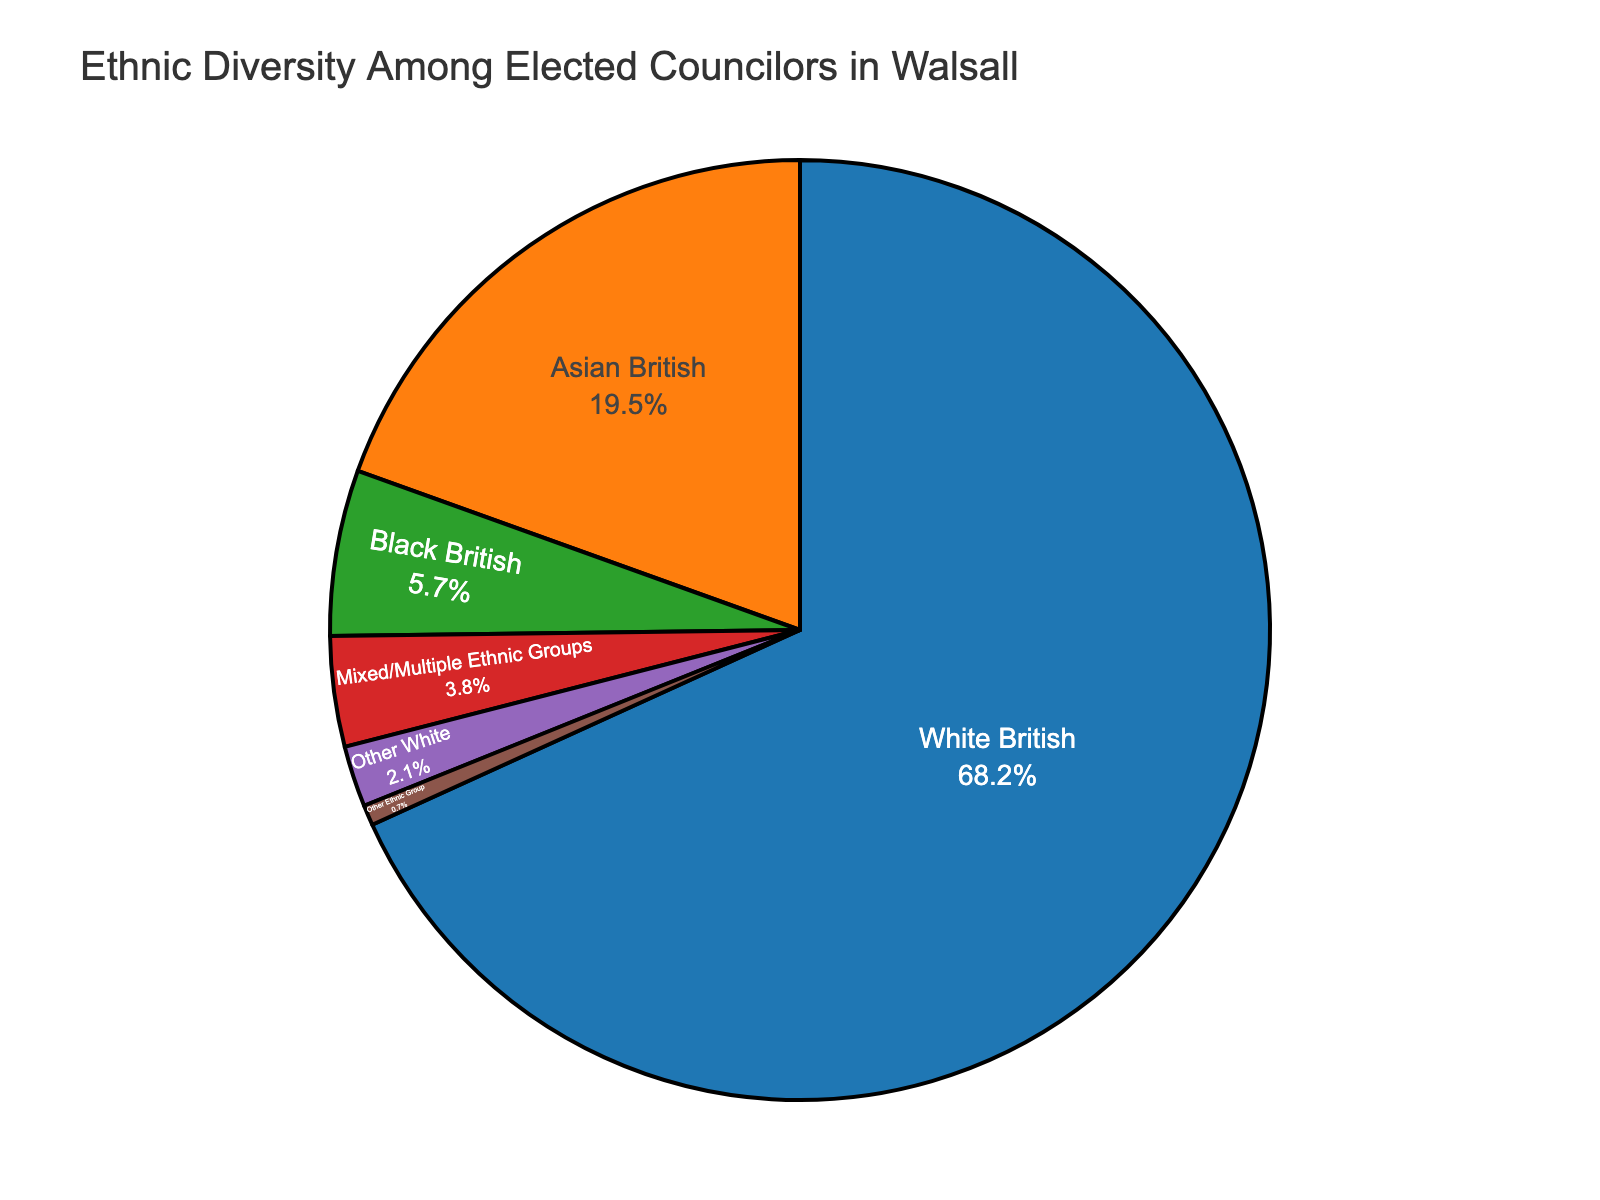Which ethnic group has the largest proportion of elected councilors in Walsall? The pie chart shows the proportion of each ethnic group among the elected councilors. The largest segment is labeled "White British."
Answer: White British What is the combined percentage of elected councilors from Asian British and Black British ethnic groups? Find the percentages for Asian British (19.5%) and Black British (5.7%) and add them together. 19.5 + 5.7 = 25.2
Answer: 25.2% Which two ethnic groups have the smallest representation among the elected councilors? The pie chart segments for "Other White" (2.1%) and "Other Ethnic Group" (0.7%) are the smallest.
Answer: Other White and Other Ethnic Group How much larger is the proportion of White British elected councilors compared to Mixed/Multiple Ethnic Groups? The percentage for White British is 68.2% and for Mixed/Multiple Ethnic Groups is 3.8%. Subtract 3.8 from 68.2. 68.2 - 3.8 = 64.4
Answer: 64.4% What percentage of the elected councilors do not belong to the White British, Asian British, or Black British groups? The other groups are Mixed/Multiple Ethnic Groups (3.8%), Other White (2.1%), and Other Ethnic Group (0.7%). Sum these percentages: 3.8 + 2.1 + 0.7 = 6.6%
Answer: 6.6% Is there a visual cue associated with the highest proportion of elected councilors? If yes, describe it. Yes, the largest segment of the pie chart is associated with "White British" and has a distinct color that stands out due to its size and position.
Answer: Yes, a large segment What's the difference in the proportion of elected councilors between Asian British and Black British groups? The percentage for Asian British is 19.5% and for Black British is 5.7%. Subtract 5.7 from 19.5. 19.5 - 5.7 = 13.8
Answer: 13.8% How does the representation of Asian British councilors compare visually to that of Other White councilors on the pie chart? The segment for Asian British is significantly larger than the segment for Other White, indicating a higher proportion visually.
Answer: Significantly larger What is the combined percentage of the three least represented ethnic groups among the elected councilors? The least represented groups are Black British (5.7%), Other White (2.1%), and Other Ethnic Group (0.7%). Sum these percentages: 5.7 + 2.1 + 0.7 = 8.5%
Answer: 8.5% 